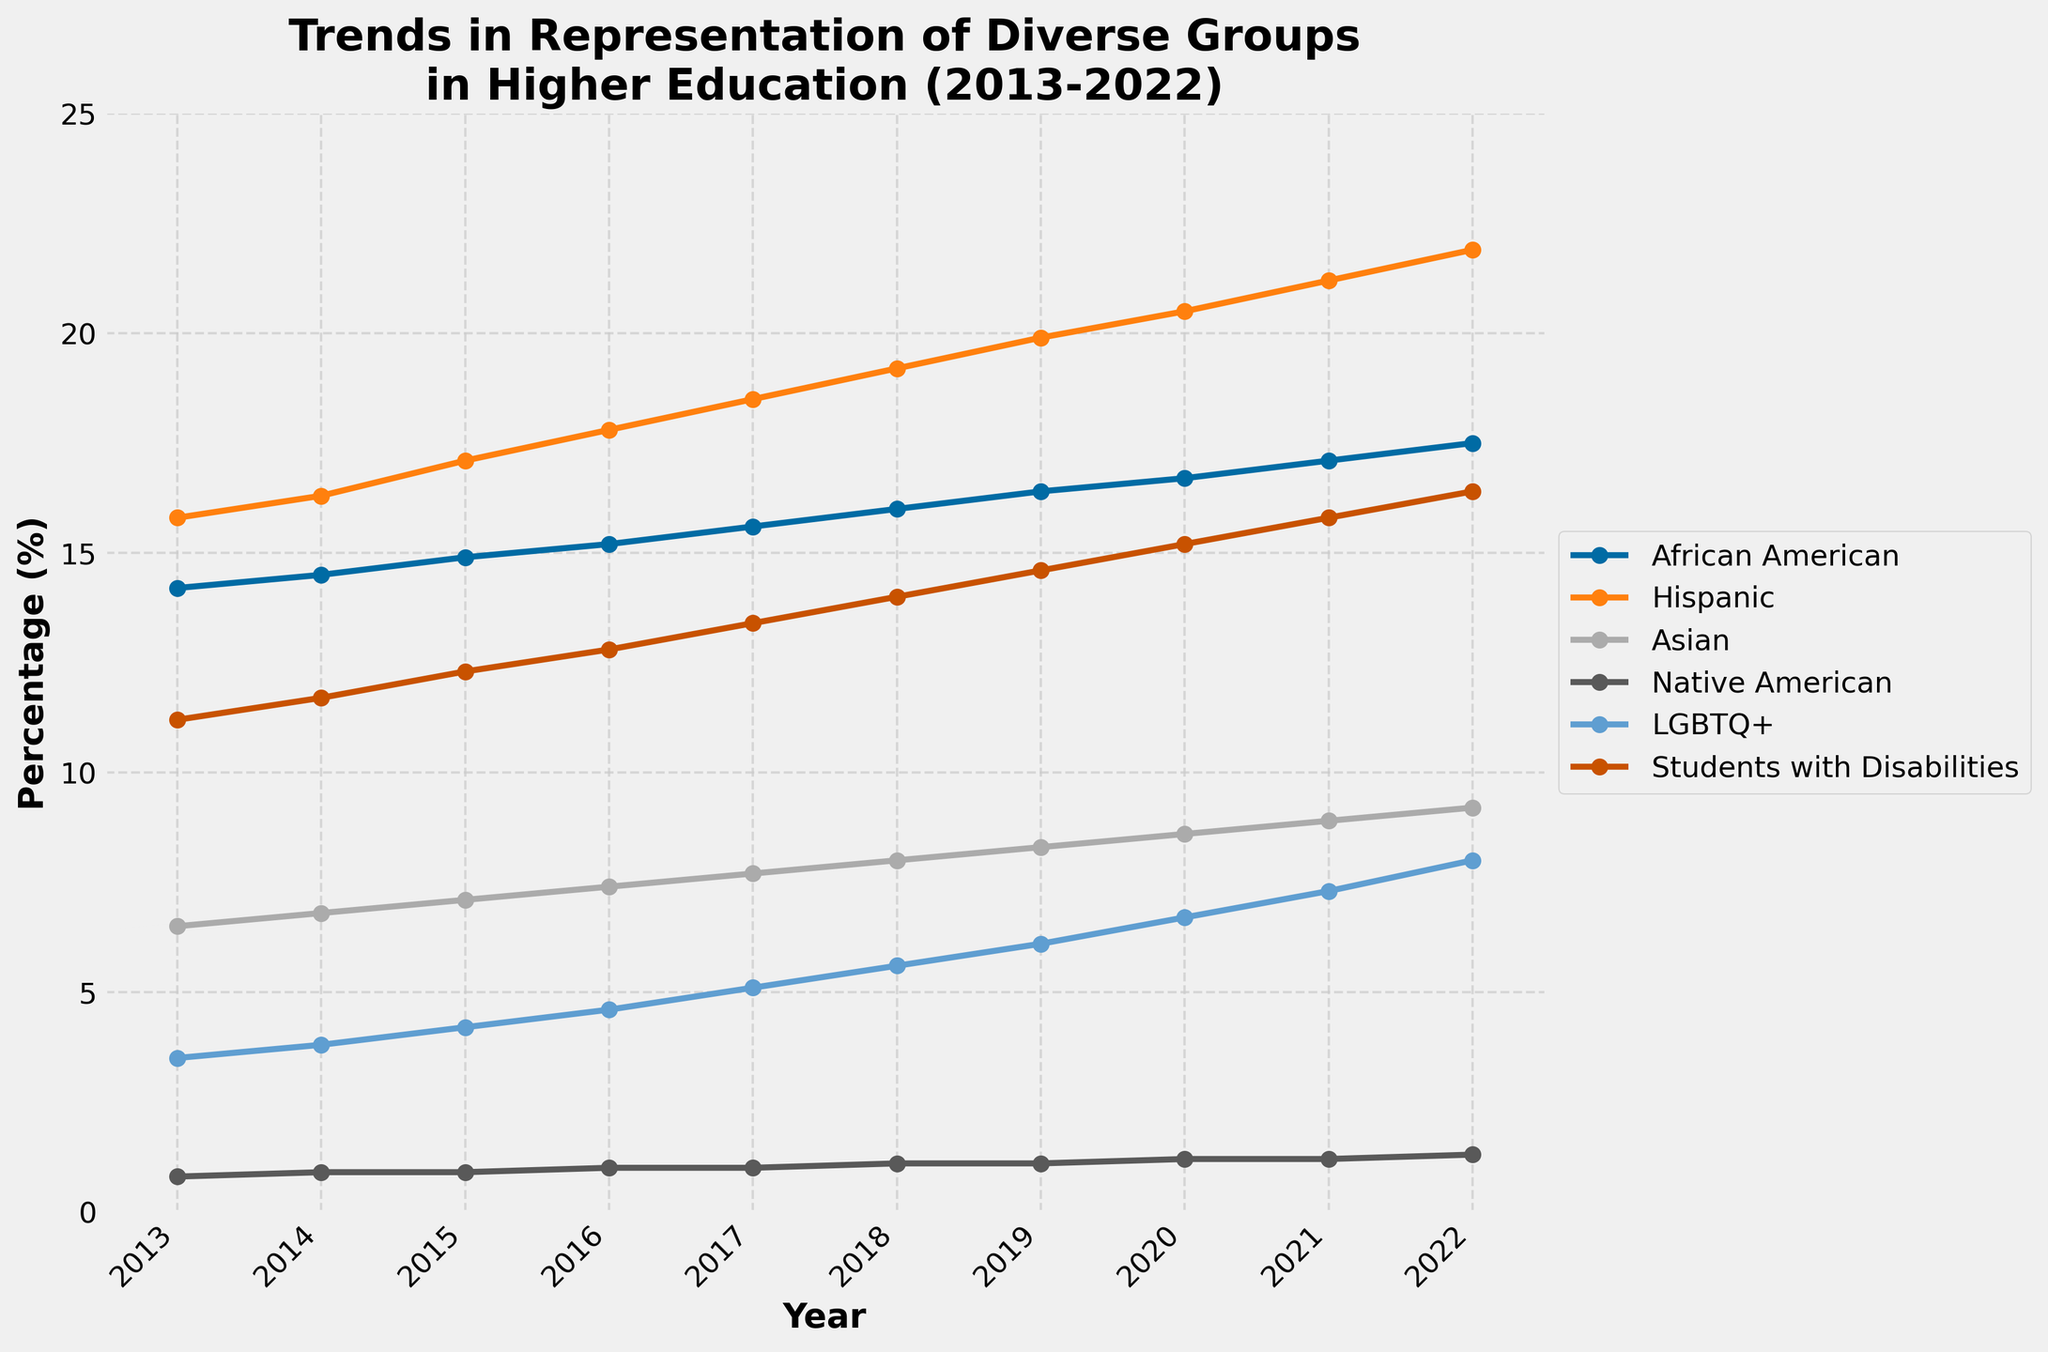Which group had the highest representation in 2022? Observing the endpoints of the lines in 2022, the Hispanic group has the highest percentage.
Answer: Hispanic Which group showed the most significant increase in representation from 2013 to 2022? Calculate the difference for each group by subtracting the 2013 value from the 2022 value. The Hispanic group has the largest increase (21.9 - 15.8 = 6.1).
Answer: Hispanic What is the average representation of African American students over the decade? Sum the values of African American representation from 2013 to 2022 and divide by the number of years (10). The calculation is (14.2 + 14.5 + 14.9 + 15.2 + 15.6 + 16 + 16.4 + 16.7 + 17.1 + 17.5) / 10.
Answer: 15.61 In which year did the representation of Native American students first reach or exceed 1.0%? Look at the line for Native American students to find when it first reaches or surpasses 1.0%. This happens in 2016.
Answer: 2016 How did the representation of Students with Disabilities change from 2018 to 2022? Subtract the 2018 value from the 2022 value for Students with Disabilities (16.4 - 14.0).
Answer: 2.4 Compare the representation of Asian and LGBTQ+ groups in 2017. Which was higher? Look at the endpoints for 2017 of both the Asian and LGBTQ+ lines. The LGBTQ+ group's value is 5.1%, while the Asian group's value is 7.7%.
Answer: Asian What is the total increase in representation for the LGBTQ+ group from 2013 to 2022? Subtract the 2013 value from the 2022 value for the LGBTQ+ group (8.0 - 3.5).
Answer: 4.5 What is the rate of change per year in the representation of the Hispanic group from 2013 to 2022? Divide the difference in values from 2013 to 2022 by the number of years (21.9 - 15.8) / (2022 - 2013).
Answer: 0.68 per year Which group's representation was consistently below 2% throughout the decade? Look at the lines and identify the group that always remains below 2%. This is the Native American group.
Answer: Native American 